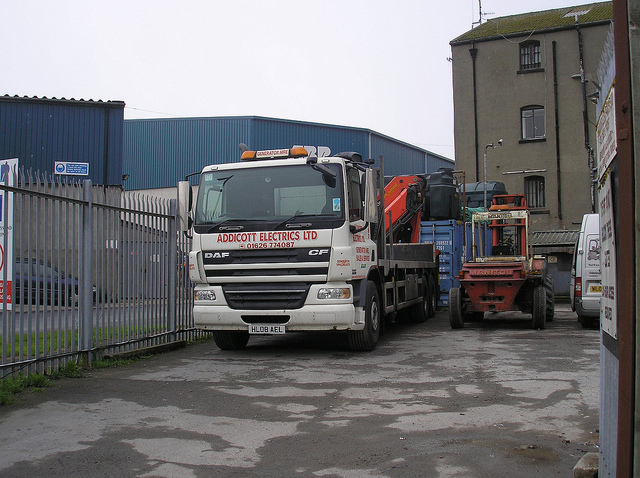Read all the text in this image. LTD ELECTRONICS ADDICOTT DAF CF TEL HLOB 01626TT4087 